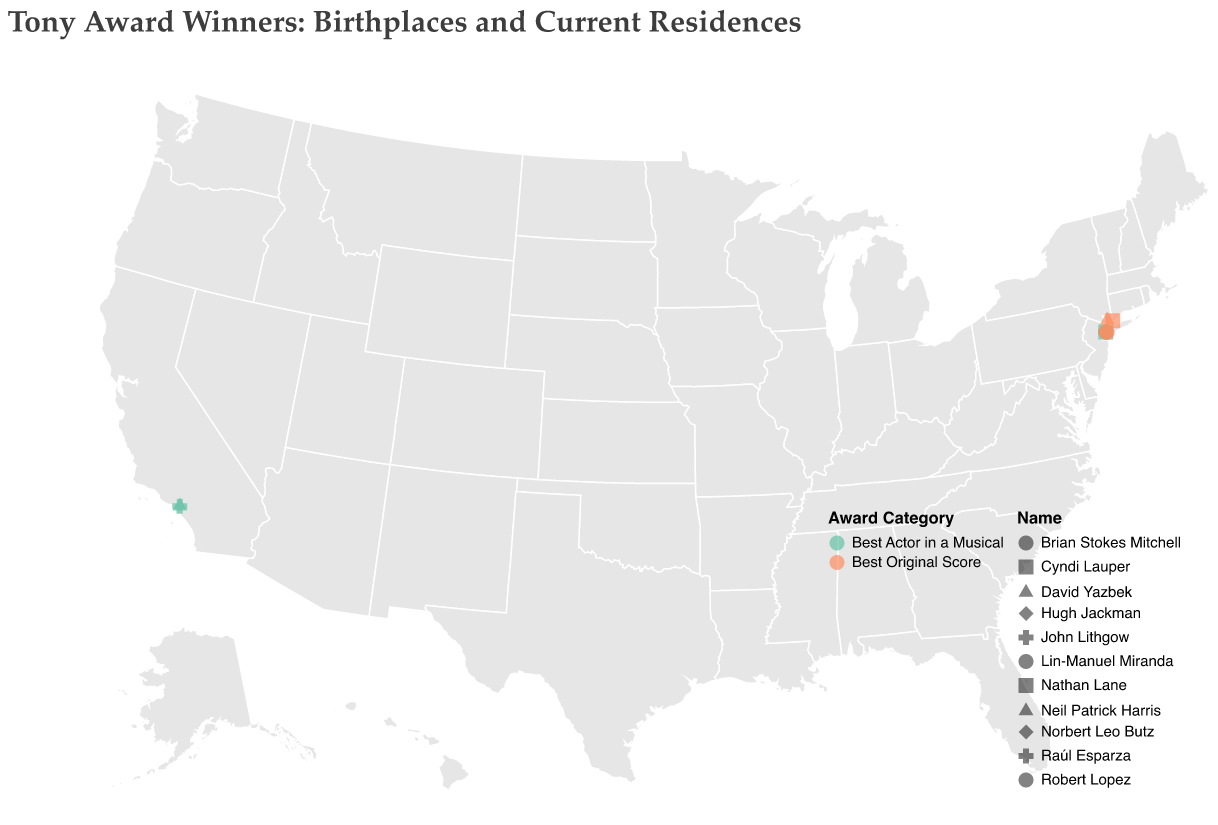How many Tony Award winners currently reside in New York NY? According to the map, the Tony Award winners residing in New York NY are Raúl Esparza, Norbert Leo Butz, Brian Stokes Mitchell, Nathan Lane, Hugh Jackman, and Lin-Manuel Miranda. Counting them gives us a total of six winners.
Answer: 6 Which winners have the same birthplace and current residence? From the figure, we see that Lin-Manuel Miranda, Robert Lopez, and David Yazbek have New York NY as both their birthplace and current residence.
Answer: Lin-Manuel Miranda, Robert Lopez, David Yazbek Is Raúl Esparza the only winner with Wilmington DE as their birthplace? The birthplace shown for Raúl Esparza is Wilmington DE. None of the other winners have Wilmington DE listed as a birthplace.
Answer: Yes Who among the winners currently reside in Los Angeles CA? The plot shows two winners residing in Los Angeles CA: Neil Patrick Harris and John Lithgow.
Answer: Neil Patrick Harris, John Lithgow How many Tony Award winners were born in New York? The birthplaces listed for New York NY include Lin-Manuel Miranda, Robert Lopez, and David Yazbek. Counting these gives us three winners born in New York NY.
Answer: 3 What is the distance relationship between Raúl Esparza's birthplace and his current residence? Raúl Esparza's birthplace is Wilmington DE, and his current residence is New York NY. Both locations are on the Eastern Seaboard, and the distance estimation would require more detailed geographical knowledge or map calculation but they are relatively close.
Answer: Relatively close Which categories have winners currently residing in New York NY? The categories with winners in New York NY include "Best Actor in a Musical" and "Best Original Score". Specifically, Raúl Esparza (Best Actor in a Musical), Norbert Leo Butz (Best Actor in a Musical), Brian Stokes Mitchell (Best Actor in a Musical), Nathan Lane (Best Actor in a Musical), Hugh Jackman (Best Actor in a Musical), and Lin-Manuel Miranda (Best Original Score) reside there.
Answer: Best Actor in a Musical, Best Original Score Does any winner live in Connecticut? Cyndi Lauper's current residence is in Stamford CT, making her the only winner residing in Connecticut.
Answer: Yes Who were born in the Western United States? From the plot, the birthplaces in the Western United States include Seattle WA (Brian Stokes Mitchell) and Albuquerque NM (Neil Patrick Harris).
Answer: Brian Stokes Mitchell, Neil Patrick Harris 